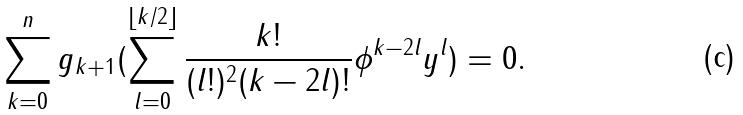<formula> <loc_0><loc_0><loc_500><loc_500>\sum _ { k = 0 } ^ { n } g _ { k + 1 } ( \sum _ { l = 0 } ^ { \lfloor k / 2 \rfloor } \frac { k ! } { ( l ! ) ^ { 2 } ( k - 2 l ) ! } \phi ^ { k - 2 l } y ^ { l } ) = 0 .</formula> 